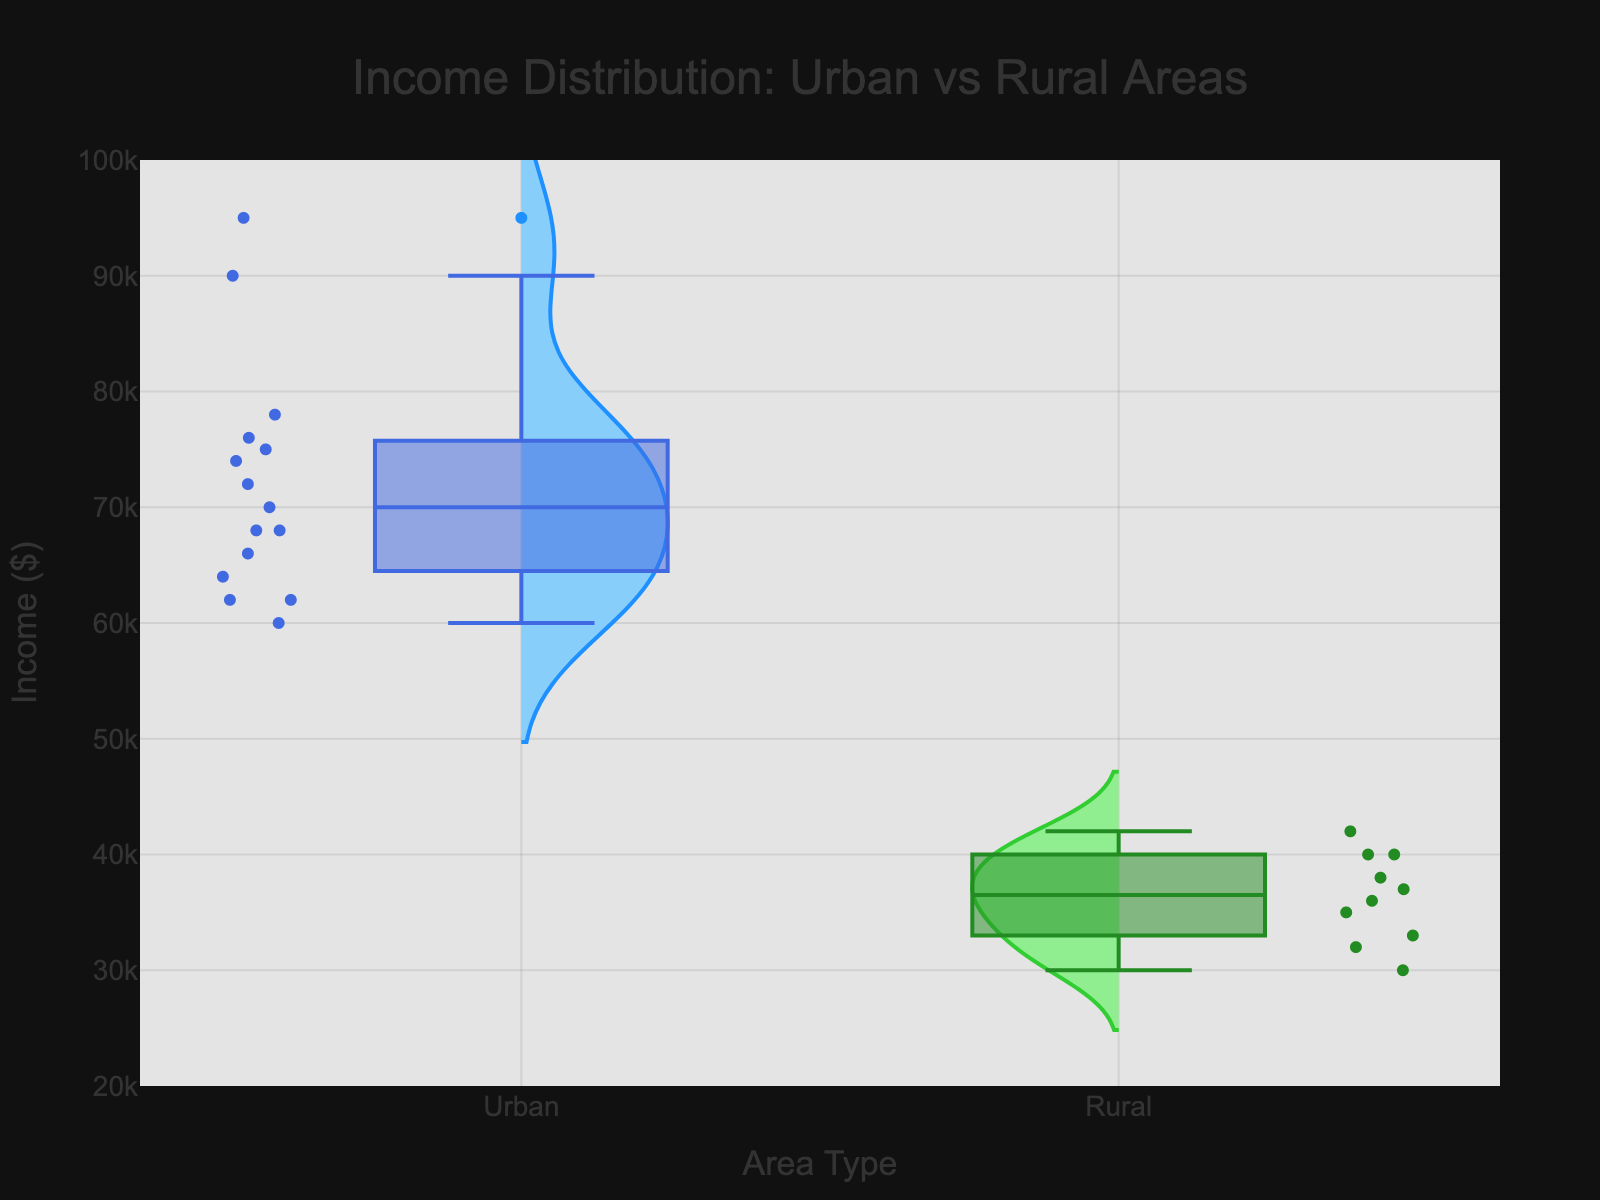What is the title of the chart? The title is clearly labeled at the top of the chart. The title provides the context for what the viewer is observing.
Answer: "Income Distribution: Urban vs Rural Areas" What is the range of incomes in rural areas? To find the range, look for the lowest and highest income values in the rural violin plot. The y-axis provides the scale, allowing us to determine these values. The rural area plot ranges from about 30,000 to 42,000.
Answer: 30,000 to 42,000 Which area type has the higher median income? Medians are represented by the line inside the box plot. By comparing these lines, we can see which one lies higher on the y-axis. The median for urban areas is higher than that for rural areas.
Answer: Urban What is the primary difference in the income distribution shapes between urban and rural areas? Examine the shape of the violin plots. Urban areas show a wider spread and a more symmetrical distribution around the median, whereas rural areas have a narrower spread with more clustering around lower income values.
Answer: Urban areas have a wider spread and symmetry, rural areas are more clustered around lower incomes How does the variability in income compare between urban and rural areas? Variability can be assessed by the width and spread of the violin plot. Urban areas exhibit a larger spread indicated by a wider plot, signifying more variability, while rural areas show a more concentrated plot around lower income values, indicating less variability.
Answer: Urban areas have more variability Which area type shows greater interquartile range (IQR)? The IQR is represented by the length of the box in the box plot. By comparing the lengths, it is evident that urban areas have a longer box compared to rural areas, suggesting a larger IQR.
Answer: Urban Are there any outliers in the income data for rural areas? Outliers are typically represented by individual points that lie outside the whiskers in a box plot. Inspecting the rural area box plot, we do not see any such points; hence, no outliers are present.
Answer: No Where would you expect the mean income to lie in urban areas relative to the median? In a generally symmetrical distribution with a few outliers, the mean tends to lie near the median. For urban areas, the symmetry and lack of extremities suggests the mean would be close to the median.
Answer: Near the median Which state has the widest spread of incomes for urban areas? By observing the description and which states have greater variability, we can identify California as having the widest spread, showing higher variation between its urban constituencies like Los Angeles and San Francisco.
Answer: California 